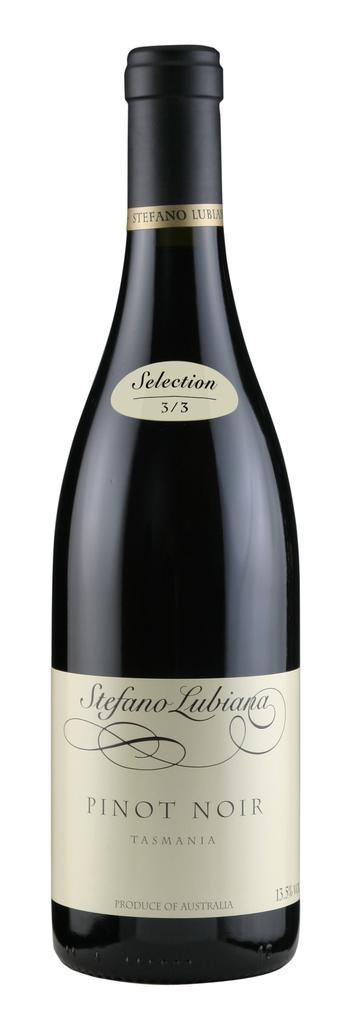What object can be seen in the image? There is a bottle in the image. What is written on the bottle? There is text written on the bottle. What type of comfort can be seen in the image? There is no comfort present in the image; it only features a bottle with text on it. 